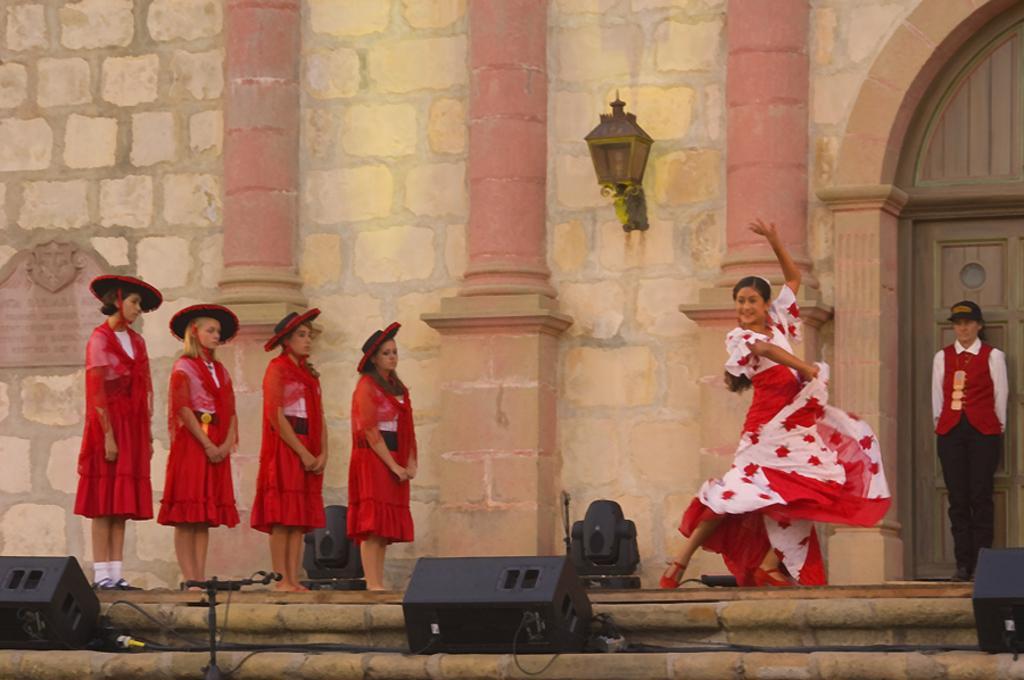Can you describe this image briefly? In this image there is a woman dancing on the floor. On the left side there are four girls who are standing one beside the other by wearing the red costume. In the background there is a wall to which there is a light. On the right side there is another girl who is standing near the door. At the bottom there are speakers and wires. In the middle there is a mic at the bottom. 